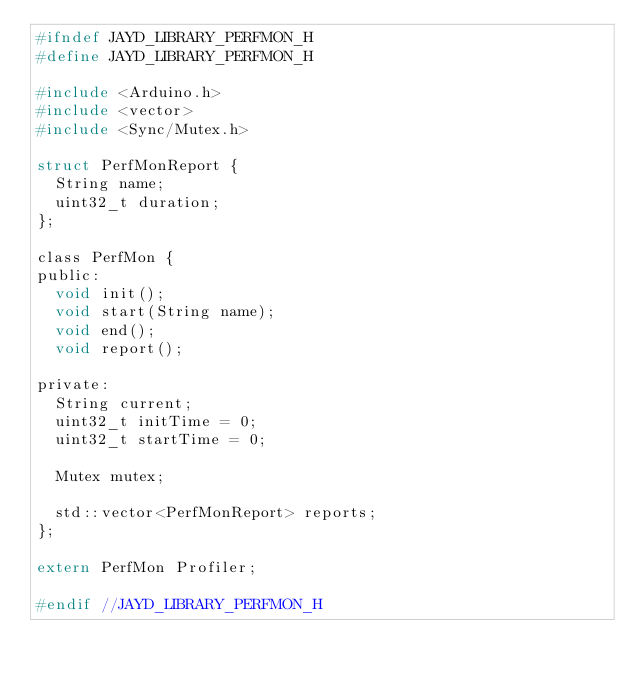Convert code to text. <code><loc_0><loc_0><loc_500><loc_500><_C_>#ifndef JAYD_LIBRARY_PERFMON_H
#define JAYD_LIBRARY_PERFMON_H

#include <Arduino.h>
#include <vector>
#include <Sync/Mutex.h>

struct PerfMonReport {
	String name;
	uint32_t duration;
};

class PerfMon {
public:
	void init();
	void start(String name);
	void end();
	void report();

private:
	String current;
	uint32_t initTime = 0;
	uint32_t startTime = 0;

	Mutex mutex;

	std::vector<PerfMonReport> reports;
};

extern PerfMon Profiler;

#endif //JAYD_LIBRARY_PERFMON_H
</code> 